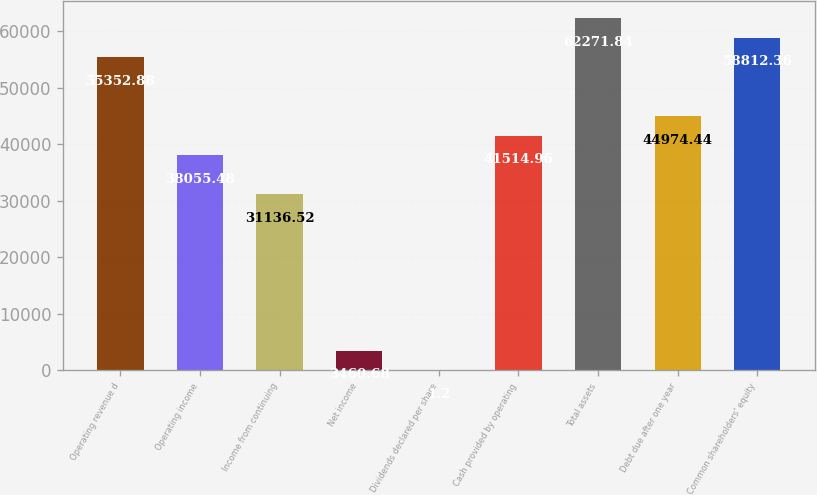<chart> <loc_0><loc_0><loc_500><loc_500><bar_chart><fcel>Operating revenue d<fcel>Operating income<fcel>Income from continuing<fcel>Net income<fcel>Dividends declared per share<fcel>Cash provided by operating<fcel>Total assets<fcel>Debt due after one year<fcel>Common shareholders' equity<nl><fcel>55352.9<fcel>38055.5<fcel>31136.5<fcel>3460.68<fcel>1.2<fcel>41515<fcel>62271.8<fcel>44974.4<fcel>58812.4<nl></chart> 